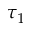Convert formula to latex. <formula><loc_0><loc_0><loc_500><loc_500>\tau _ { 1 }</formula> 